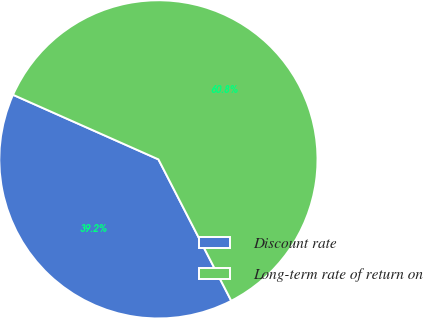<chart> <loc_0><loc_0><loc_500><loc_500><pie_chart><fcel>Discount rate<fcel>Long-term rate of return on<nl><fcel>39.22%<fcel>60.78%<nl></chart> 